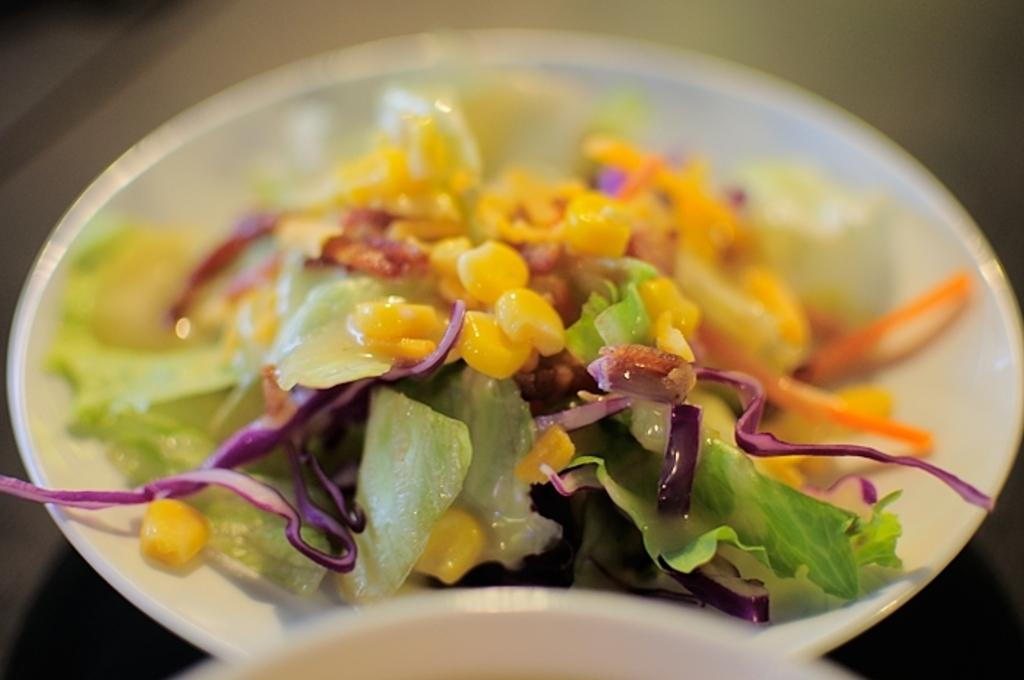What is present on the plate in the image? There is a food item on the plate in the image. Can you describe the food item on the plate? Unfortunately, the specific food item cannot be determined from the provided facts. What type of dress is the food item wearing in the image? There is no dress present in the image, as the food item is not a person or animate object. 